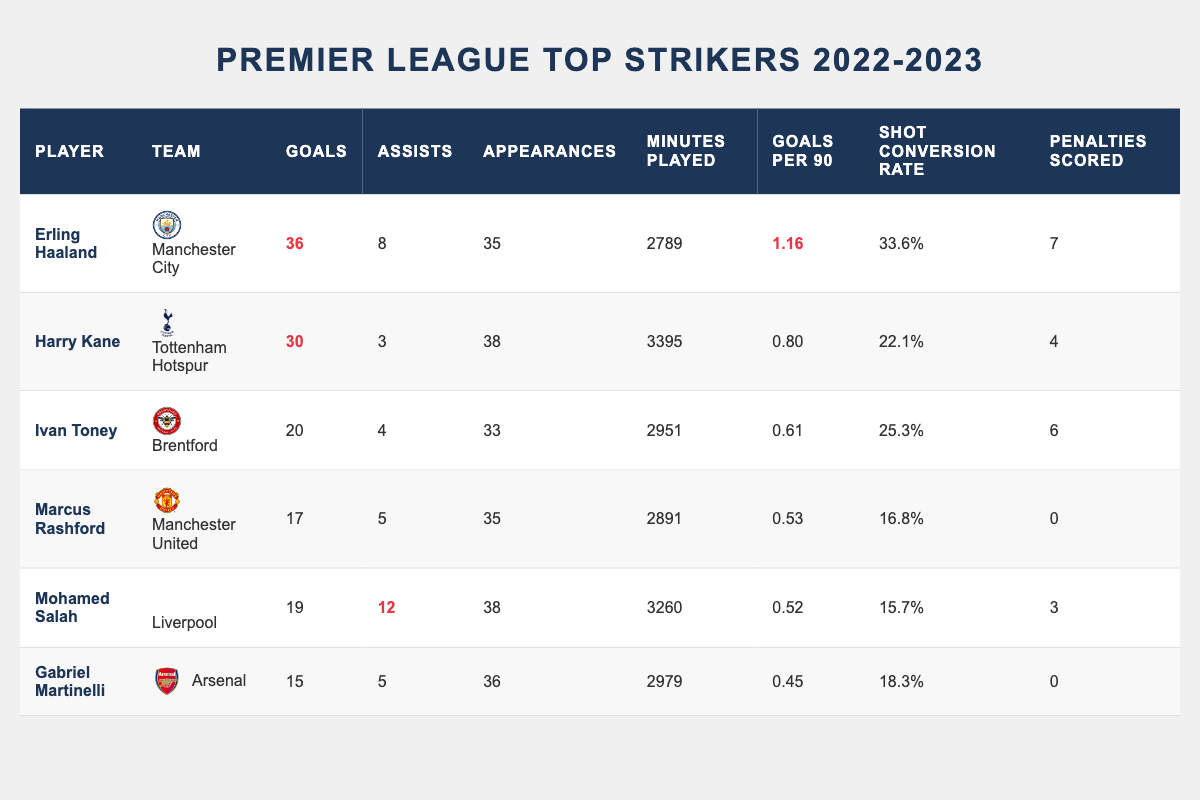What is the total number of goals scored by all players in the table? To calculate the total goals, we add the goals scored by each player: 36 (Haaland) + 30 (Kane) + 20 (Toney) + 17 (Rashford) + 19 (Salah) + 15 (Martinelli) = 137
Answer: 137 Who had the highest goals per 90 minutes and what was the value? By looking at the "Goals per 90" column, Erling Haaland has the highest value at 1.16
Answer: 1.16 Did Marcus Rashford score more goals than Mohamed Salah? By comparing the goals scored, Marcus Rashford has 17 goals, while Mohamed Salah has 19 goals, so Rashford did not score more.
Answer: No What is the average goals scored by the players in the table? To find the average, sum the goals (137) and divide by the number of players (6). The average is 137 / 6 = approximately 22.83
Answer: 22.83 Which player scored the most penalties and how many? By checking the "Penalties Scored" column, Erling Haaland scored the most penalties with 7.
Answer: 7 How many assists did Harry Kane provide, and how does this compare to Erling Haaland? Harry Kane had 3 assists, while Erling Haaland had 8 assists. Therefore, Haaland provided 5 more assists than Kane (8 - 3 = 5).
Answer: 5 Is it true that Gabriel Martinelli has a higher shot conversion rate than Marcus Rashford? Gabriel Martinelli's shot conversion rate is 18.3% while Marcus Rashford's is 16.8%. Therefore, it is true that Martinelli has a higher conversion rate.
Answer: Yes What was the total number of appearances by all players in the table? To find the total appearances, we add each player's appearances: 35 + 38 + 33 + 35 + 38 + 36 = 215
Answer: 215 Among the players listed, who had the least number of goals scored? By looking at the "Goals" column, Gabriel Martinelli scored the least with 15 goals.
Answer: 15 How many goals did Ivan Toney score compared to Marcus Rashford? Ivan Toney scored 20 goals while Marcus Rashford scored 17 goals, meaning Toney scored 3 more goals than Rashford (20 - 17 = 3).
Answer: 3 